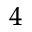Convert formula to latex. <formula><loc_0><loc_0><loc_500><loc_500>^ { \, 4 }</formula> 